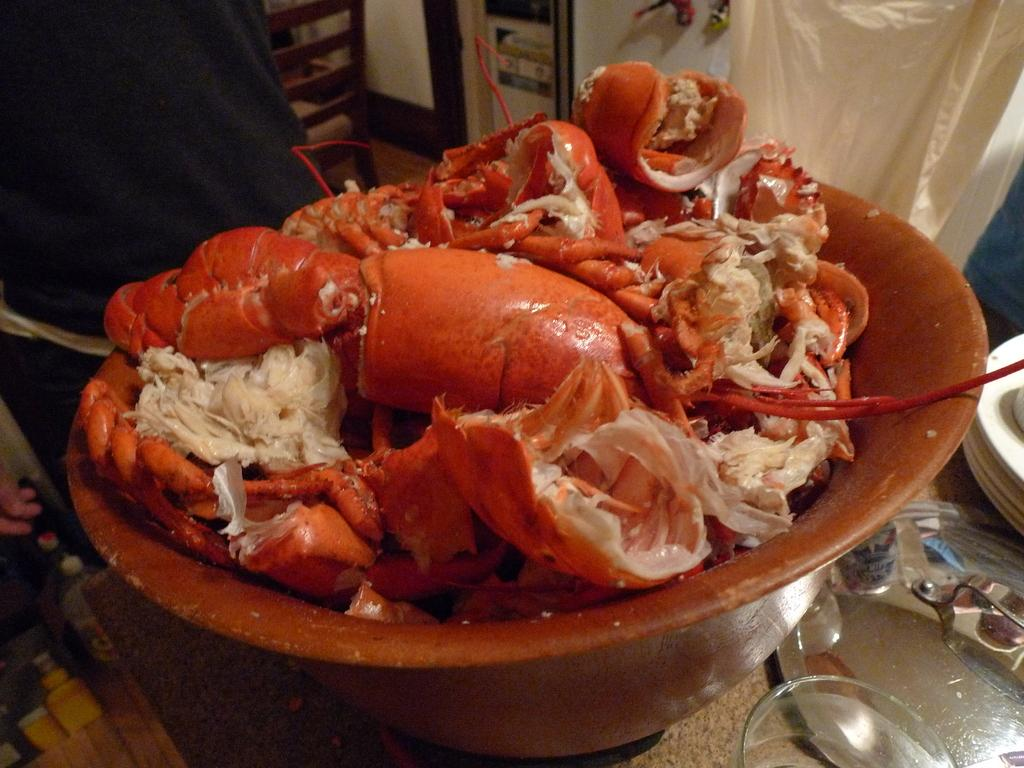What type of food is in the bowl in the image? There is crab meat in a bowl in the image. What can be seen in the background of the image? There is a chairperson, utensils, and a cloth in the background of the image. What type of verse can be heard being recited by the crab in the image? There is no crab present in the image, and therefore no verse can be heard being recited. 